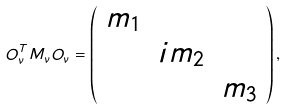<formula> <loc_0><loc_0><loc_500><loc_500>O _ { \nu } ^ { T } M _ { \nu } O _ { \nu } = \left ( \begin{array} { c c c } m _ { 1 } & & \\ & i m _ { 2 } & \\ & & m _ { 3 } \\ \end{array} \right ) ,</formula> 